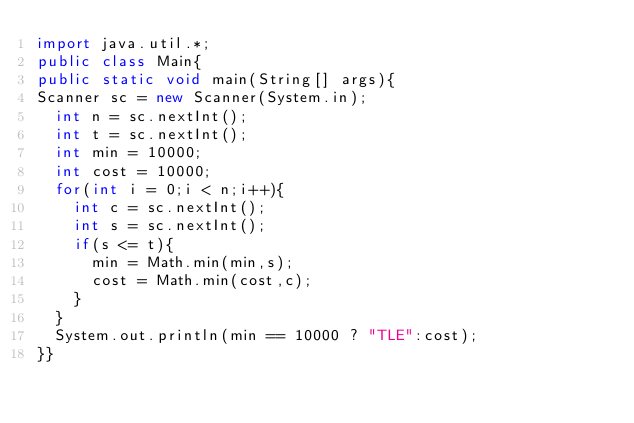<code> <loc_0><loc_0><loc_500><loc_500><_Java_>import java.util.*;
public class Main{
public static void main(String[] args){
Scanner sc = new Scanner(System.in);
  int n = sc.nextInt();
  int t = sc.nextInt();
  int min = 10000;
  int cost = 10000;
  for(int i = 0;i < n;i++){
    int c = sc.nextInt();
    int s = sc.nextInt();
    if(s <= t){
      min = Math.min(min,s);
      cost = Math.min(cost,c);
    }
  }
  System.out.println(min == 10000 ? "TLE":cost);
}}
</code> 